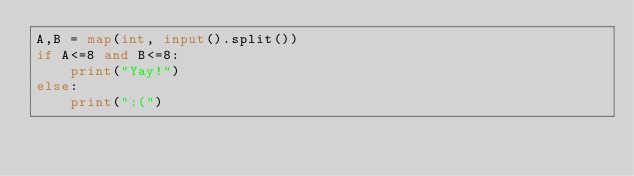<code> <loc_0><loc_0><loc_500><loc_500><_Python_>A,B = map(int, input().split())
if A<=8 and B<=8:
	print("Yay!")
else:
	print(":(")
</code> 